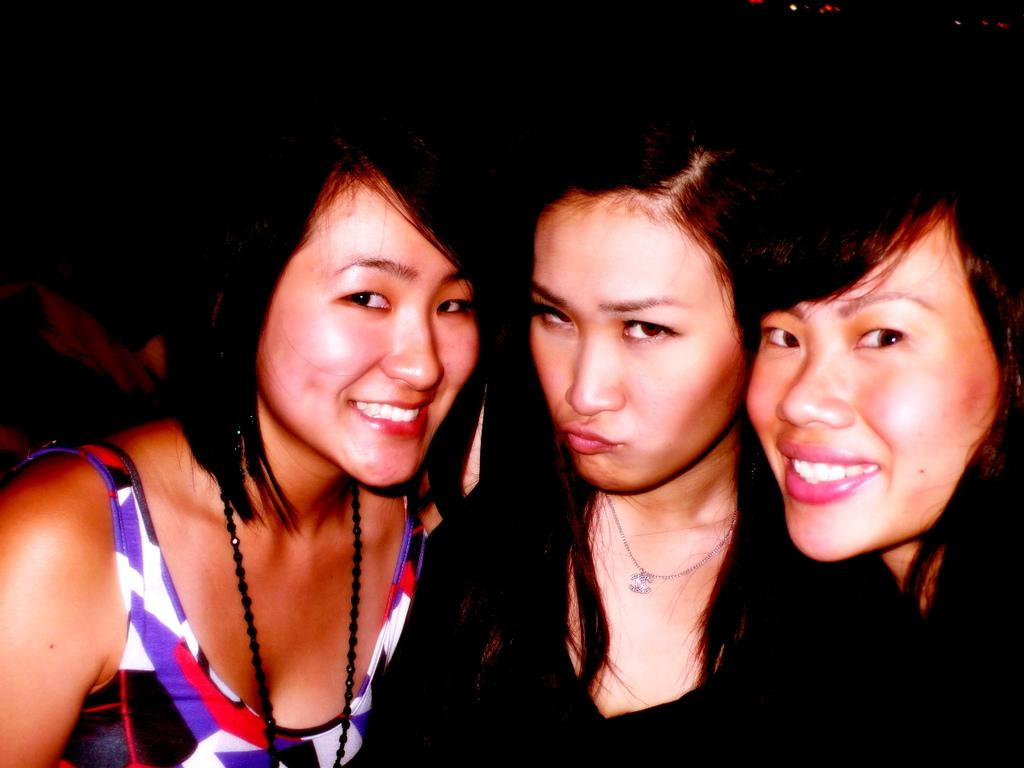How many women are in the image? There are three women in the image. What are the women wearing? Two of the women are wearing black dresses. What can be observed about the background of the image? The background of the image is dark. What type of sticks are the women using to join the pail in the image? There are no sticks or pails present in the image. 